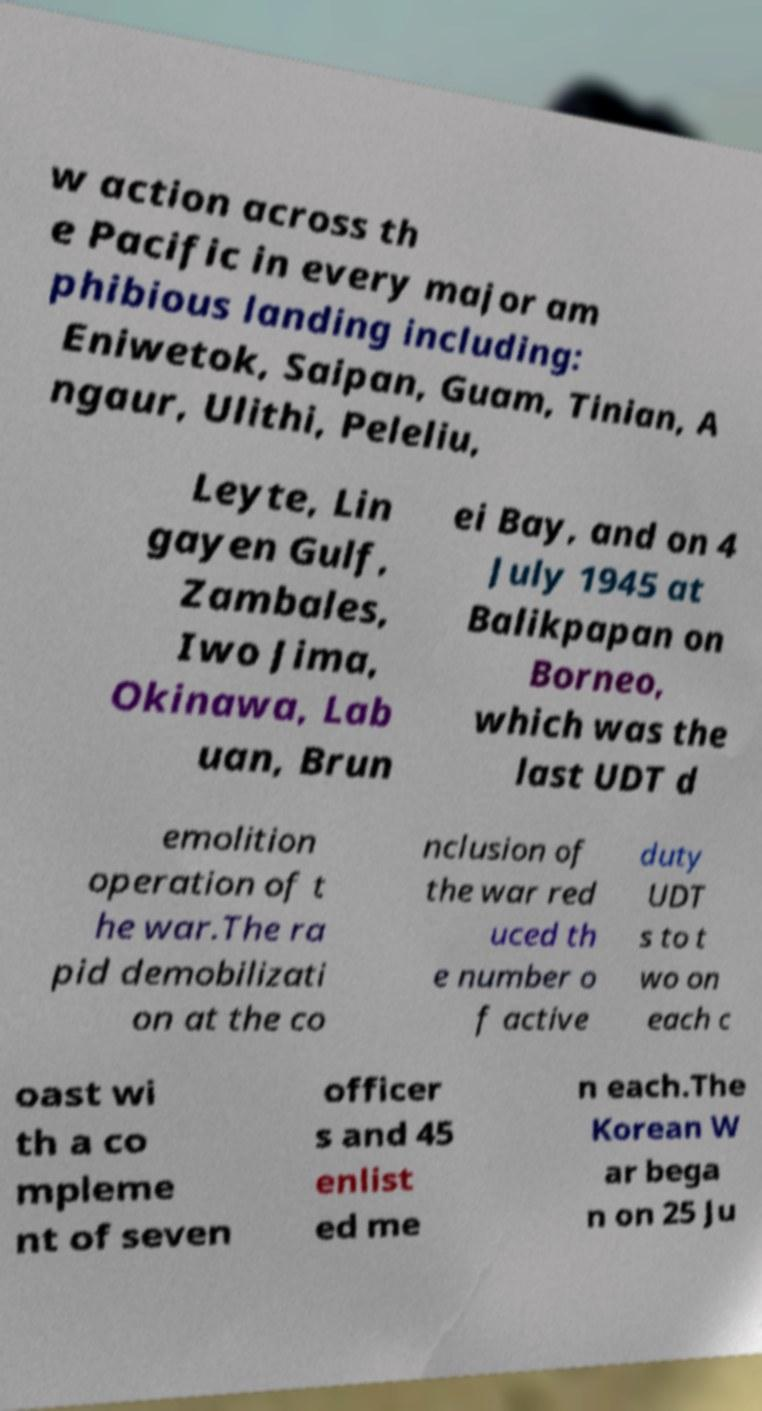Could you extract and type out the text from this image? w action across th e Pacific in every major am phibious landing including: Eniwetok, Saipan, Guam, Tinian, A ngaur, Ulithi, Peleliu, Leyte, Lin gayen Gulf, Zambales, Iwo Jima, Okinawa, Lab uan, Brun ei Bay, and on 4 July 1945 at Balikpapan on Borneo, which was the last UDT d emolition operation of t he war.The ra pid demobilizati on at the co nclusion of the war red uced th e number o f active duty UDT s to t wo on each c oast wi th a co mpleme nt of seven officer s and 45 enlist ed me n each.The Korean W ar bega n on 25 Ju 